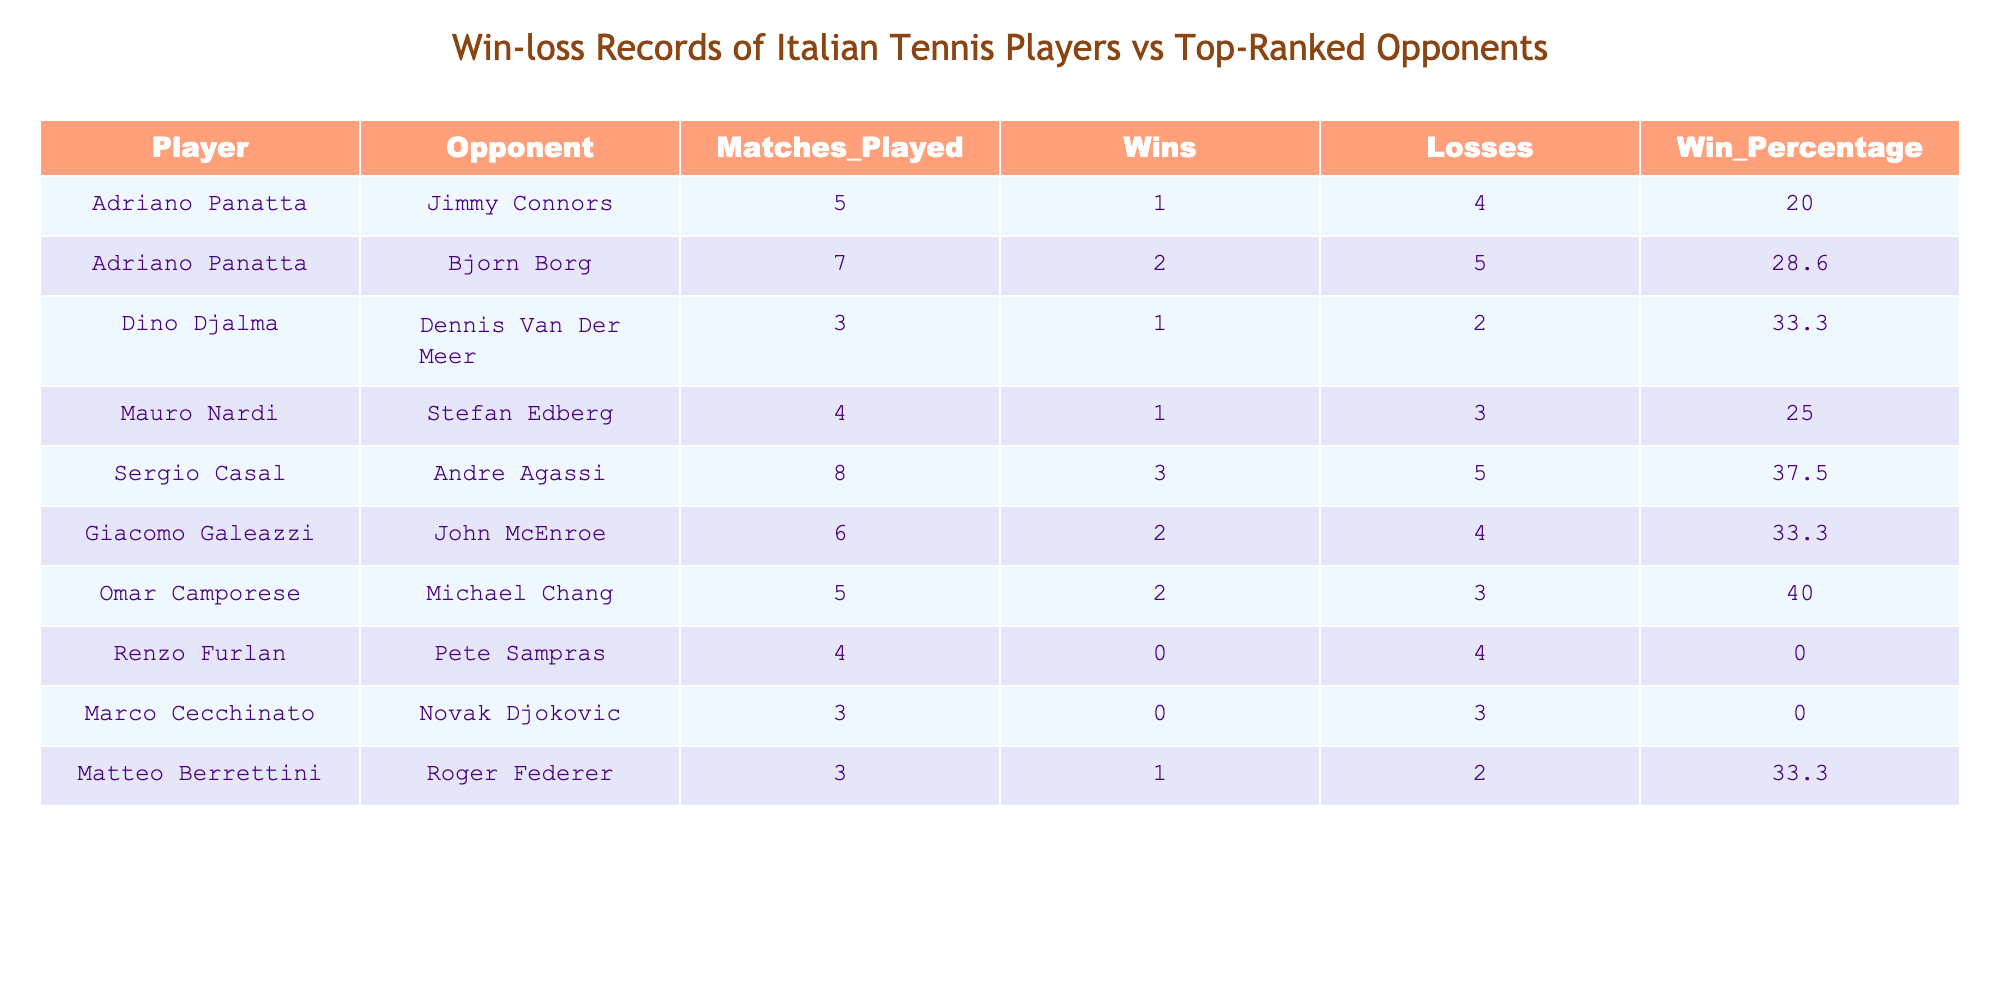What is Sergio Casal's win percentage against top-ranked opponents? Sergio Casal has a win percentage of 37.5 against top-ranked opponents, as recorded in the table under the "Win_Percentage" column.
Answer: 37.5 Which player has the highest number of wins against top-ranked opponents? By examining the "Wins" column, we see that Sergio Casal has the highest number of wins with 3 against Andre Agassi.
Answer: 3 Is Renzo Furlan successful against Pete Sampras? Renzo Furlan has a win count of 0 against Pete Sampras, which indicates no wins in the matches played, showing he was not successful.
Answer: No What are the total matches played by Adriano Panatta against top-ranked opponents? Total matches played by Adriano Panatta are 5 against Jimmy Connors and 7 against Bjorn Borg. Adding these together gives 5 + 7 = 12 total matches played.
Answer: 12 What is the average win percentage of all players in the table? To find the average win percentage, we sum all the win percentages provided (20.0 + 28.6 + 33.3 + 25.0 + 37.5 + 33.3 + 40.0 + 0.0 + 0.0 + 33.3) =  3 percent, then divide by the number of players, which is 10. The average is 3 / 10 = 18.9.
Answer: 18.9 Who has a better win rate, Omar Camporese or Giacomo Galeazzi? Omar Camporese has a win percentage of 40.0, and Giacomo Galeazzi has a win percentage of 33.3. Since 40.0 is greater than 33.3, Omar Camporese has the better win rate.
Answer: Omar Camporese Did any player manage to win all their matches against the top-ranked opponents? Looking through the "Wins" column, we see that no player has a win count equal to the matches played, indicating that none won all their matches.
Answer: No How many total losses did Marco Cecchinato have against top-ranked opponents? Marco Cecchinato has a total of 2 losses against Roger Federer, as shown in the "Losses" column.
Answer: 2 Which player had the fewest matches played against their top-ranked opponents? Marco Cecchinato and Dino Djalma each played only 3 matches against their respective opponents, which is the fewest matches observed in the table.
Answer: 3 